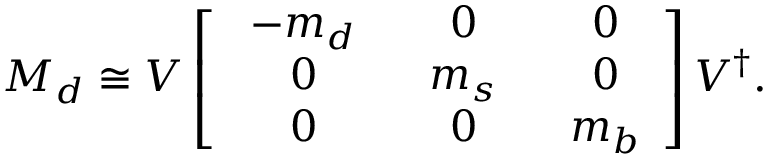Convert formula to latex. <formula><loc_0><loc_0><loc_500><loc_500>M _ { d } \cong V \left [ \begin{array} { c c c } { { \ - m _ { d } \ } } & { \ 0 \ } & { \ 0 } \\ { \ 0 \ } & { { \ m _ { s } \ } } & { \ 0 } \\ { \ 0 \ } & { \ 0 \ } & { { \ m _ { b } } } \end{array} \right ] V ^ { \dagger } .</formula> 